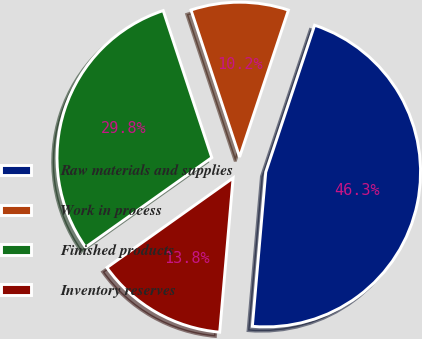Convert chart. <chart><loc_0><loc_0><loc_500><loc_500><pie_chart><fcel>Raw materials and supplies<fcel>Work in process<fcel>Finished products<fcel>Inventory reserves<nl><fcel>46.27%<fcel>10.19%<fcel>29.75%<fcel>13.79%<nl></chart> 